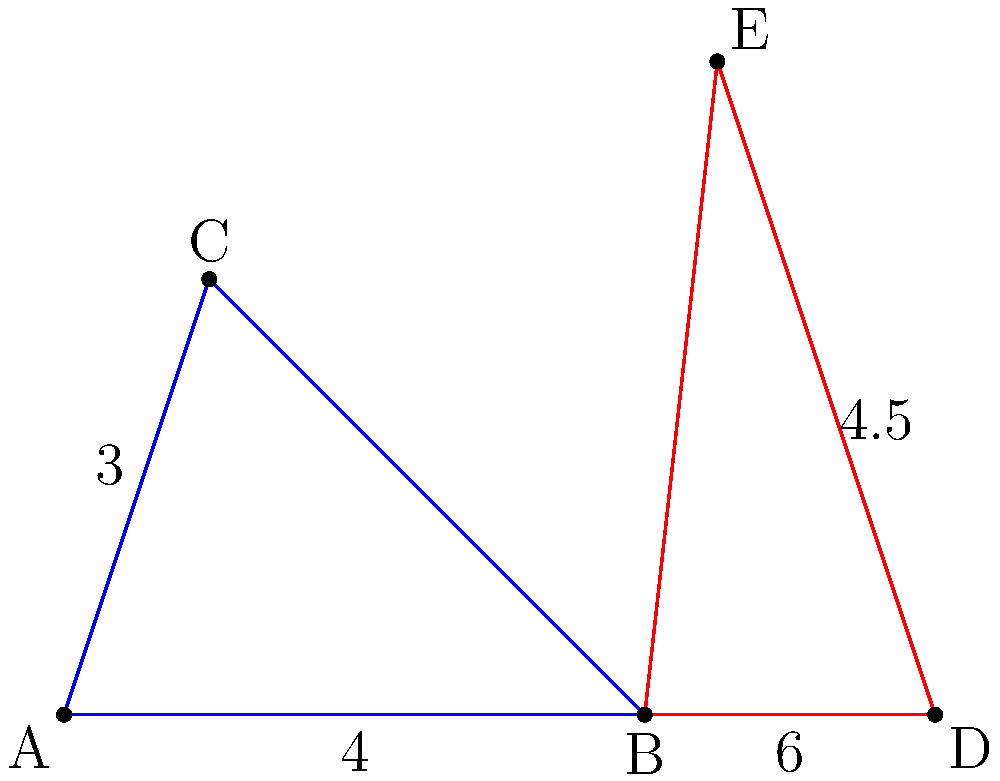In the diagram, triangle ABC is similar to triangle BDE. If the height of triangle ABC is 3 units and its base is 4 units, while the base of triangle BDE is 6 units, what is the area of triangle BDE? Justify your answer using the properties of similar triangles. Let's approach this step-by-step:

1) First, recall that in similar triangles, the ratio of corresponding sides is constant. Let's call this ratio $r$. We can find $r$ using the bases of the triangles:

   $r = \frac{BD}{AB} = \frac{6}{4} = 1.5$

2) Since the triangles are similar, this ratio applies to all corresponding sides, including the heights. If we call the height of BDE $h$, we can write:

   $\frac{h}{3} = 1.5$

3) Solving for $h$:

   $h = 3 * 1.5 = 4.5$ units

4) Now we have the base and height of triangle BDE. Recall the formula for the area of a triangle:

   $Area = \frac{1}{2} * base * height$

5) Plugging in our values:

   $Area_{BDE} = \frac{1}{2} * 6 * 4.5 = 13.5$ square units

6) We can verify this using the property that the ratio of areas of similar triangles is the square of the ratio of their sides:

   $\frac{Area_{BDE}}{Area_{ABC}} = r^2 = 1.5^2 = 2.25$

   $Area_{ABC} = \frac{1}{2} * 4 * 3 = 6$ square units

   $Area_{BDE} = 6 * 2.25 = 13.5$ square units

Thus, we confirm our result using two methods.
Answer: 13.5 square units 